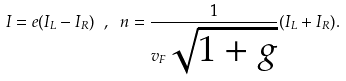Convert formula to latex. <formula><loc_0><loc_0><loc_500><loc_500>I = e ( I _ { L } - I _ { R } ) \ , \ n = \frac { 1 } { v _ { F } \sqrt { 1 + g } } ( I _ { L } + I _ { R } ) .</formula> 